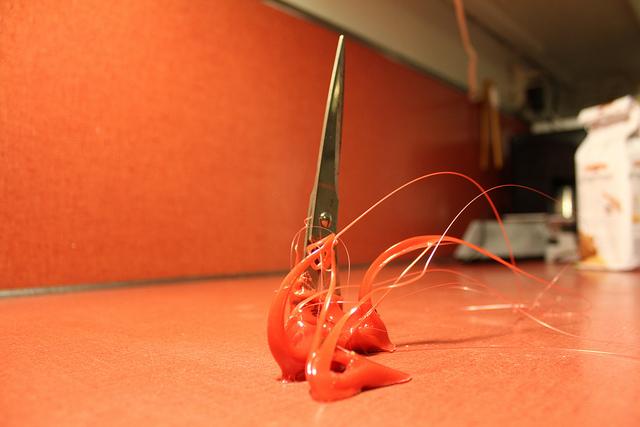Can these scissors be used for cutting?
Answer briefly. No. What color is the counter?
Short answer required. Orange. What brand of cookies is in the package?
Quick response, please. Pepperidge farms. 